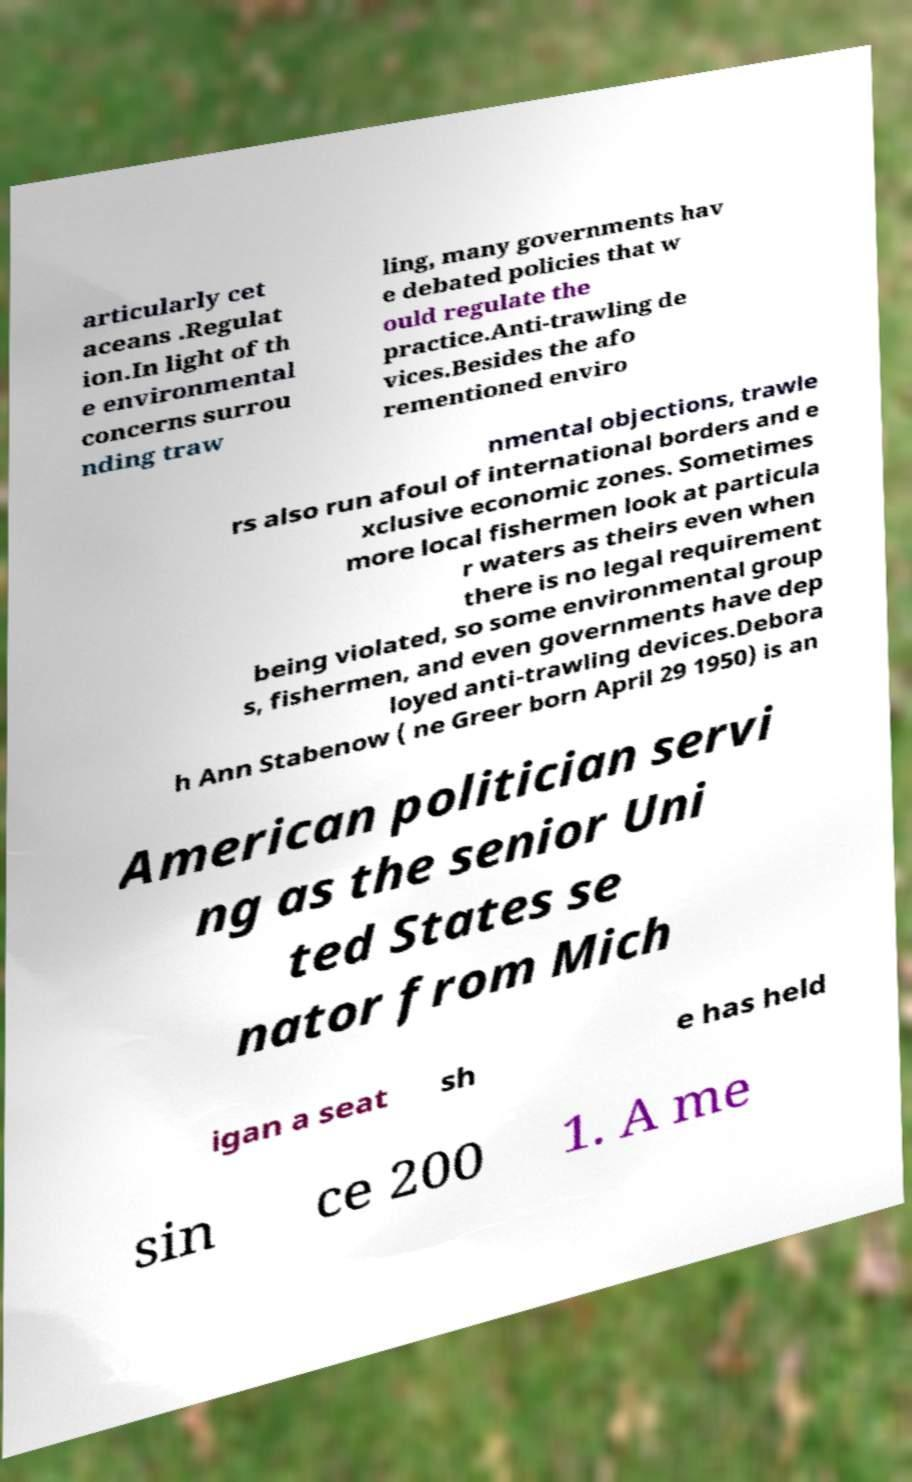What messages or text are displayed in this image? I need them in a readable, typed format. articularly cet aceans .Regulat ion.In light of th e environmental concerns surrou nding traw ling, many governments hav e debated policies that w ould regulate the practice.Anti-trawling de vices.Besides the afo rementioned enviro nmental objections, trawle rs also run afoul of international borders and e xclusive economic zones. Sometimes more local fishermen look at particula r waters as theirs even when there is no legal requirement being violated, so some environmental group s, fishermen, and even governments have dep loyed anti-trawling devices.Debora h Ann Stabenow ( ne Greer born April 29 1950) is an American politician servi ng as the senior Uni ted States se nator from Mich igan a seat sh e has held sin ce 200 1. A me 